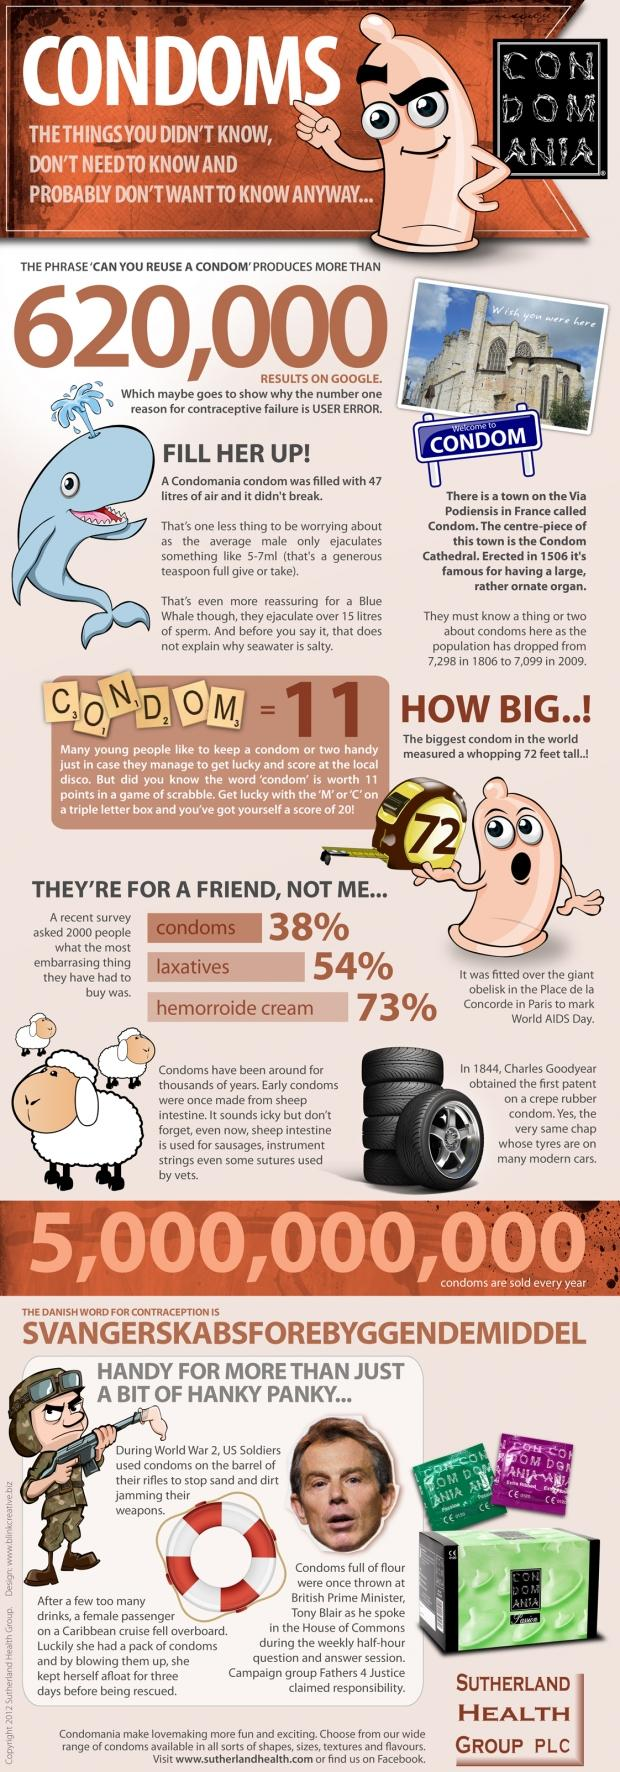Indicate a few pertinent items in this graphic. It is widely known that Tony Blair, a famous person, was thrown with condoms. 